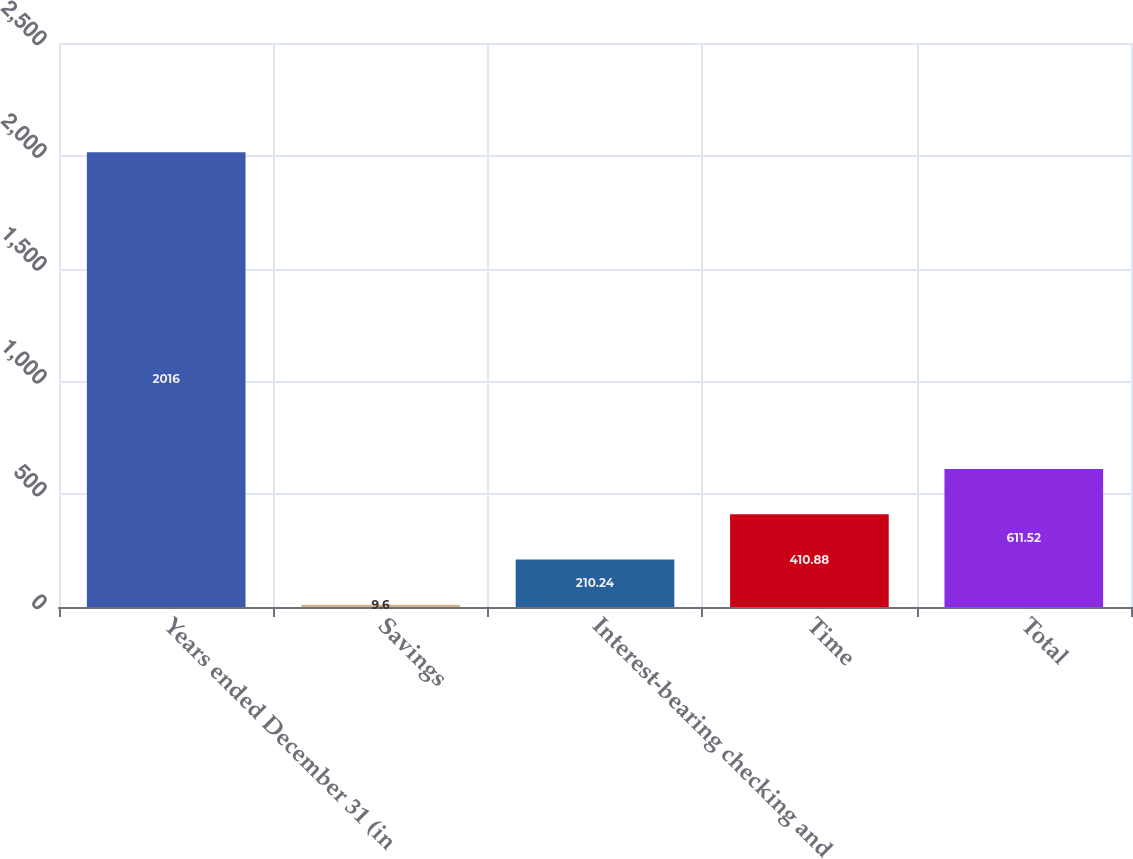Convert chart to OTSL. <chart><loc_0><loc_0><loc_500><loc_500><bar_chart><fcel>Years ended December 31 (in<fcel>Savings<fcel>Interest-bearing checking and<fcel>Time<fcel>Total<nl><fcel>2016<fcel>9.6<fcel>210.24<fcel>410.88<fcel>611.52<nl></chart> 